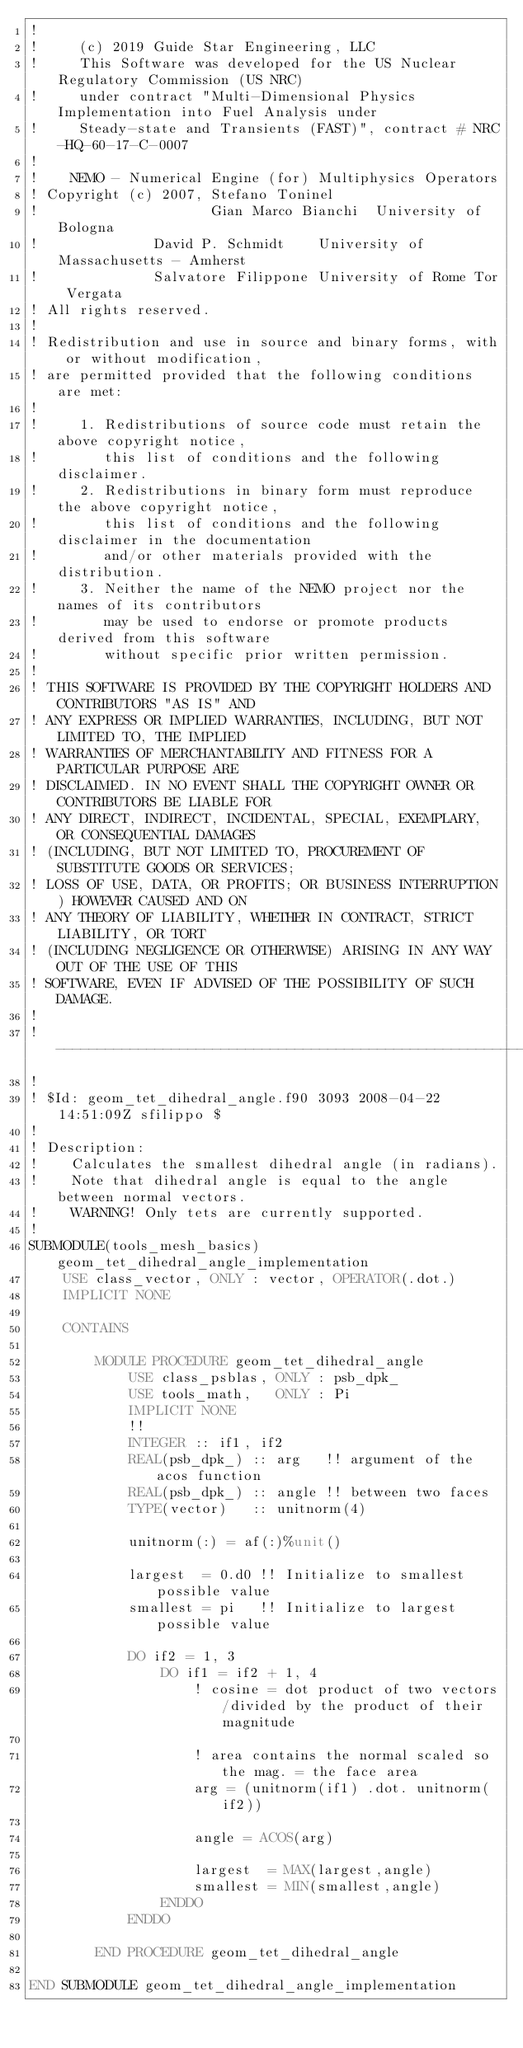<code> <loc_0><loc_0><loc_500><loc_500><_FORTRAN_>!
!     (c) 2019 Guide Star Engineering, LLC
!     This Software was developed for the US Nuclear Regulatory Commission (US NRC)
!     under contract "Multi-Dimensional Physics Implementation into Fuel Analysis under
!     Steady-state and Transients (FAST)", contract # NRC-HQ-60-17-C-0007
!
!    NEMO - Numerical Engine (for) Multiphysics Operators
! Copyright (c) 2007, Stefano Toninel
!                     Gian Marco Bianchi  University of Bologna
!              David P. Schmidt    University of Massachusetts - Amherst
!              Salvatore Filippone University of Rome Tor Vergata
! All rights reserved.
!
! Redistribution and use in source and binary forms, with or without modification,
! are permitted provided that the following conditions are met:
!
!     1. Redistributions of source code must retain the above copyright notice,
!        this list of conditions and the following disclaimer.
!     2. Redistributions in binary form must reproduce the above copyright notice,
!        this list of conditions and the following disclaimer in the documentation
!        and/or other materials provided with the distribution.
!     3. Neither the name of the NEMO project nor the names of its contributors
!        may be used to endorse or promote products derived from this software
!        without specific prior written permission.
!
! THIS SOFTWARE IS PROVIDED BY THE COPYRIGHT HOLDERS AND CONTRIBUTORS "AS IS" AND
! ANY EXPRESS OR IMPLIED WARRANTIES, INCLUDING, BUT NOT LIMITED TO, THE IMPLIED
! WARRANTIES OF MERCHANTABILITY AND FITNESS FOR A PARTICULAR PURPOSE ARE
! DISCLAIMED. IN NO EVENT SHALL THE COPYRIGHT OWNER OR CONTRIBUTORS BE LIABLE FOR
! ANY DIRECT, INDIRECT, INCIDENTAL, SPECIAL, EXEMPLARY, OR CONSEQUENTIAL DAMAGES
! (INCLUDING, BUT NOT LIMITED TO, PROCUREMENT OF SUBSTITUTE GOODS OR SERVICES;
! LOSS OF USE, DATA, OR PROFITS; OR BUSINESS INTERRUPTION) HOWEVER CAUSED AND ON
! ANY THEORY OF LIABILITY, WHETHER IN CONTRACT, STRICT LIABILITY, OR TORT
! (INCLUDING NEGLIGENCE OR OTHERWISE) ARISING IN ANY WAY OUT OF THE USE OF THIS
! SOFTWARE, EVEN IF ADVISED OF THE POSSIBILITY OF SUCH DAMAGE.
!
!---------------------------------------------------------------------------------
!
! $Id: geom_tet_dihedral_angle.f90 3093 2008-04-22 14:51:09Z sfilippo $
!
! Description:
!    Calculates the smallest dihedral angle (in radians).
!    Note that dihedral angle is equal to the angle between normal vectors.
!    WARNING! Only tets are currently supported.
!
SUBMODULE(tools_mesh_basics) geom_tet_dihedral_angle_implementation
    USE class_vector, ONLY : vector, OPERATOR(.dot.)
    IMPLICIT NONE

    CONTAINS

        MODULE PROCEDURE geom_tet_dihedral_angle
            USE class_psblas, ONLY : psb_dpk_
            USE tools_math,   ONLY : Pi
            IMPLICIT NONE
            !!
            INTEGER :: if1, if2
            REAL(psb_dpk_) :: arg   !! argument of the acos function
            REAL(psb_dpk_) :: angle !! between two faces
            TYPE(vector)   :: unitnorm(4)

            unitnorm(:) = af(:)%unit()

            largest  = 0.d0 !! Initialize to smallest possible value
            smallest = pi   !! Initialize to largest possible value

            DO if2 = 1, 3
                DO if1 = if2 + 1, 4
                    ! cosine = dot product of two vectors/divided by the product of their magnitude

                    ! area contains the normal scaled so the mag. = the face area
                    arg = (unitnorm(if1) .dot. unitnorm(if2))

                    angle = ACOS(arg)

                    largest  = MAX(largest,angle)
                    smallest = MIN(smallest,angle)
                ENDDO
            ENDDO

        END PROCEDURE geom_tet_dihedral_angle

END SUBMODULE geom_tet_dihedral_angle_implementation
</code> 